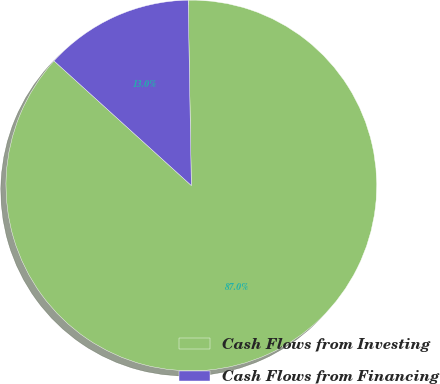Convert chart. <chart><loc_0><loc_0><loc_500><loc_500><pie_chart><fcel>Cash Flows from Investing<fcel>Cash Flows from Financing<nl><fcel>87.0%<fcel>13.0%<nl></chart> 